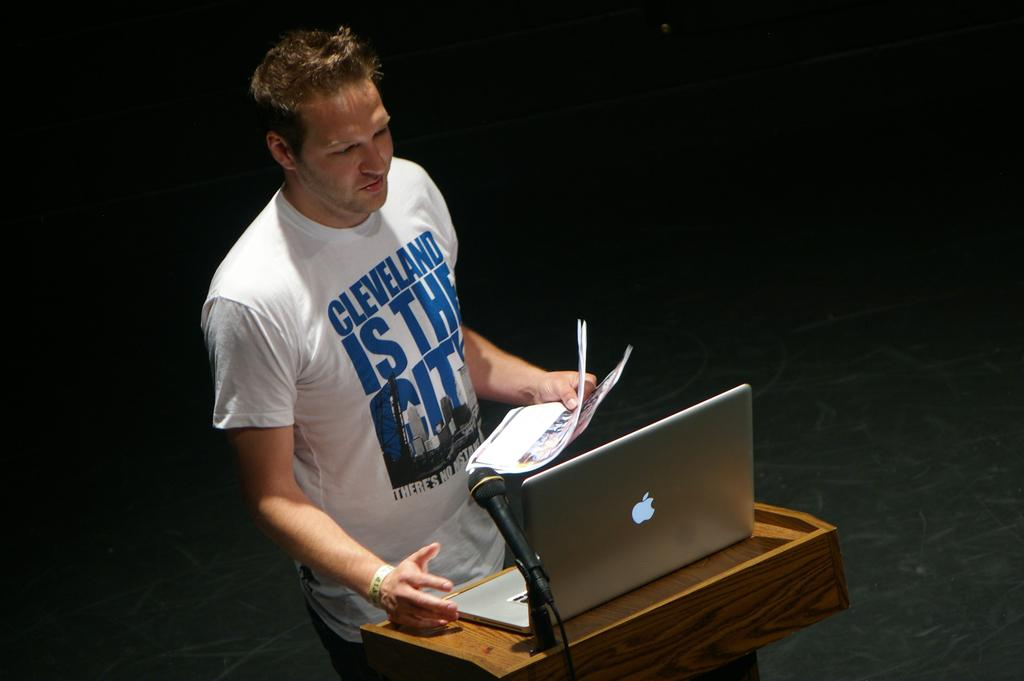Provide a one-sentence caption for the provided image. the man wearing the Cleveland is the city shirt is reading from an apple laptop. 